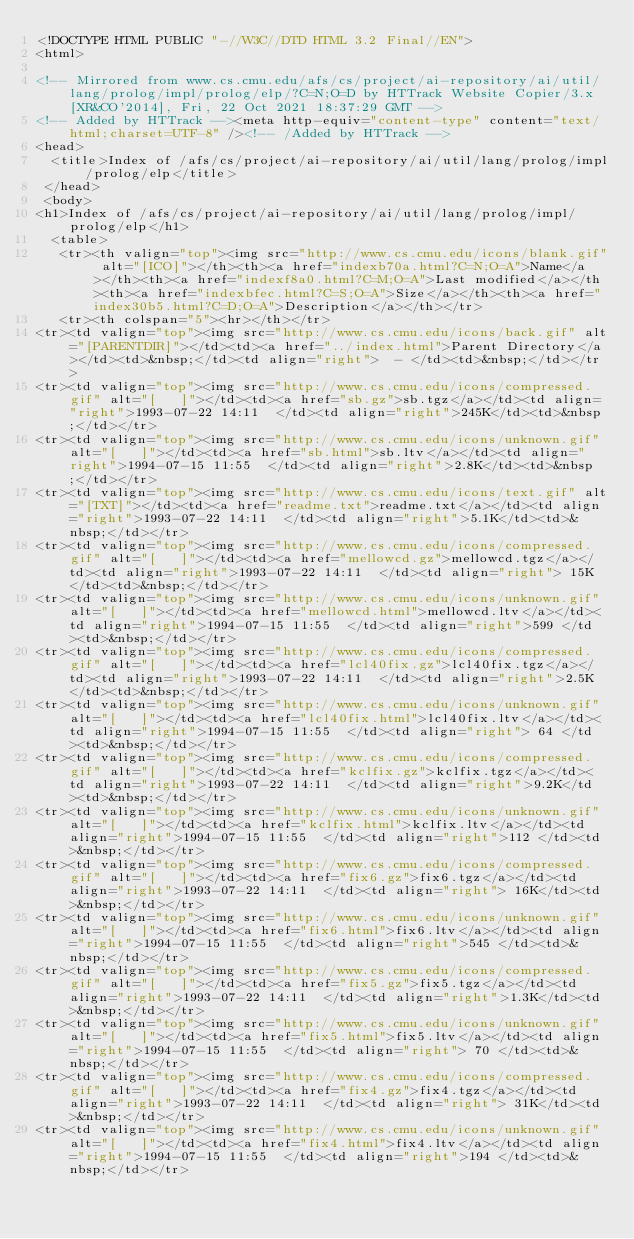Convert code to text. <code><loc_0><loc_0><loc_500><loc_500><_HTML_><!DOCTYPE HTML PUBLIC "-//W3C//DTD HTML 3.2 Final//EN">
<html>
 
<!-- Mirrored from www.cs.cmu.edu/afs/cs/project/ai-repository/ai/util/lang/prolog/impl/prolog/elp/?C=N;O=D by HTTrack Website Copier/3.x [XR&CO'2014], Fri, 22 Oct 2021 18:37:29 GMT -->
<!-- Added by HTTrack --><meta http-equiv="content-type" content="text/html;charset=UTF-8" /><!-- /Added by HTTrack -->
<head>
  <title>Index of /afs/cs/project/ai-repository/ai/util/lang/prolog/impl/prolog/elp</title>
 </head>
 <body>
<h1>Index of /afs/cs/project/ai-repository/ai/util/lang/prolog/impl/prolog/elp</h1>
  <table>
   <tr><th valign="top"><img src="http://www.cs.cmu.edu/icons/blank.gif" alt="[ICO]"></th><th><a href="indexb70a.html?C=N;O=A">Name</a></th><th><a href="indexf8a0.html?C=M;O=A">Last modified</a></th><th><a href="indexbfec.html?C=S;O=A">Size</a></th><th><a href="index30b5.html?C=D;O=A">Description</a></th></tr>
   <tr><th colspan="5"><hr></th></tr>
<tr><td valign="top"><img src="http://www.cs.cmu.edu/icons/back.gif" alt="[PARENTDIR]"></td><td><a href="../index.html">Parent Directory</a></td><td>&nbsp;</td><td align="right">  - </td><td>&nbsp;</td></tr>
<tr><td valign="top"><img src="http://www.cs.cmu.edu/icons/compressed.gif" alt="[   ]"></td><td><a href="sb.gz">sb.tgz</a></td><td align="right">1993-07-22 14:11  </td><td align="right">245K</td><td>&nbsp;</td></tr>
<tr><td valign="top"><img src="http://www.cs.cmu.edu/icons/unknown.gif" alt="[   ]"></td><td><a href="sb.html">sb.ltv</a></td><td align="right">1994-07-15 11:55  </td><td align="right">2.8K</td><td>&nbsp;</td></tr>
<tr><td valign="top"><img src="http://www.cs.cmu.edu/icons/text.gif" alt="[TXT]"></td><td><a href="readme.txt">readme.txt</a></td><td align="right">1993-07-22 14:11  </td><td align="right">5.1K</td><td>&nbsp;</td></tr>
<tr><td valign="top"><img src="http://www.cs.cmu.edu/icons/compressed.gif" alt="[   ]"></td><td><a href="mellowcd.gz">mellowcd.tgz</a></td><td align="right">1993-07-22 14:11  </td><td align="right"> 15K</td><td>&nbsp;</td></tr>
<tr><td valign="top"><img src="http://www.cs.cmu.edu/icons/unknown.gif" alt="[   ]"></td><td><a href="mellowcd.html">mellowcd.ltv</a></td><td align="right">1994-07-15 11:55  </td><td align="right">599 </td><td>&nbsp;</td></tr>
<tr><td valign="top"><img src="http://www.cs.cmu.edu/icons/compressed.gif" alt="[   ]"></td><td><a href="lcl40fix.gz">lcl40fix.tgz</a></td><td align="right">1993-07-22 14:11  </td><td align="right">2.5K</td><td>&nbsp;</td></tr>
<tr><td valign="top"><img src="http://www.cs.cmu.edu/icons/unknown.gif" alt="[   ]"></td><td><a href="lcl40fix.html">lcl40fix.ltv</a></td><td align="right">1994-07-15 11:55  </td><td align="right"> 64 </td><td>&nbsp;</td></tr>
<tr><td valign="top"><img src="http://www.cs.cmu.edu/icons/compressed.gif" alt="[   ]"></td><td><a href="kclfix.gz">kclfix.tgz</a></td><td align="right">1993-07-22 14:11  </td><td align="right">9.2K</td><td>&nbsp;</td></tr>
<tr><td valign="top"><img src="http://www.cs.cmu.edu/icons/unknown.gif" alt="[   ]"></td><td><a href="kclfix.html">kclfix.ltv</a></td><td align="right">1994-07-15 11:55  </td><td align="right">112 </td><td>&nbsp;</td></tr>
<tr><td valign="top"><img src="http://www.cs.cmu.edu/icons/compressed.gif" alt="[   ]"></td><td><a href="fix6.gz">fix6.tgz</a></td><td align="right">1993-07-22 14:11  </td><td align="right"> 16K</td><td>&nbsp;</td></tr>
<tr><td valign="top"><img src="http://www.cs.cmu.edu/icons/unknown.gif" alt="[   ]"></td><td><a href="fix6.html">fix6.ltv</a></td><td align="right">1994-07-15 11:55  </td><td align="right">545 </td><td>&nbsp;</td></tr>
<tr><td valign="top"><img src="http://www.cs.cmu.edu/icons/compressed.gif" alt="[   ]"></td><td><a href="fix5.gz">fix5.tgz</a></td><td align="right">1993-07-22 14:11  </td><td align="right">1.3K</td><td>&nbsp;</td></tr>
<tr><td valign="top"><img src="http://www.cs.cmu.edu/icons/unknown.gif" alt="[   ]"></td><td><a href="fix5.html">fix5.ltv</a></td><td align="right">1994-07-15 11:55  </td><td align="right"> 70 </td><td>&nbsp;</td></tr>
<tr><td valign="top"><img src="http://www.cs.cmu.edu/icons/compressed.gif" alt="[   ]"></td><td><a href="fix4.gz">fix4.tgz</a></td><td align="right">1993-07-22 14:11  </td><td align="right"> 31K</td><td>&nbsp;</td></tr>
<tr><td valign="top"><img src="http://www.cs.cmu.edu/icons/unknown.gif" alt="[   ]"></td><td><a href="fix4.html">fix4.ltv</a></td><td align="right">1994-07-15 11:55  </td><td align="right">194 </td><td>&nbsp;</td></tr></code> 